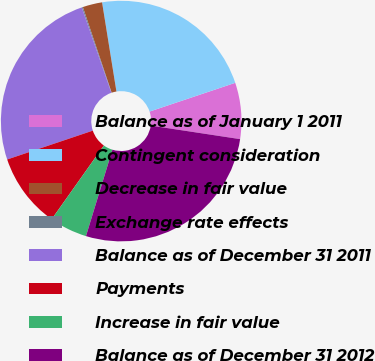Convert chart to OTSL. <chart><loc_0><loc_0><loc_500><loc_500><pie_chart><fcel>Balance as of January 1 2011<fcel>Contingent consideration<fcel>Decrease in fair value<fcel>Exchange rate effects<fcel>Balance as of December 31 2011<fcel>Payments<fcel>Increase in fair value<fcel>Balance as of December 31 2012<nl><fcel>7.55%<fcel>22.39%<fcel>2.62%<fcel>0.15%<fcel>24.86%<fcel>10.02%<fcel>5.08%<fcel>27.33%<nl></chart> 